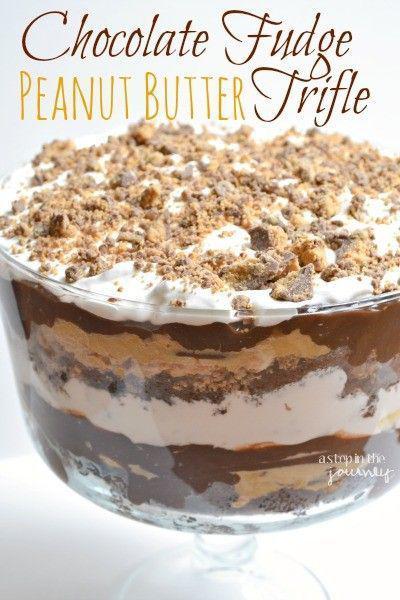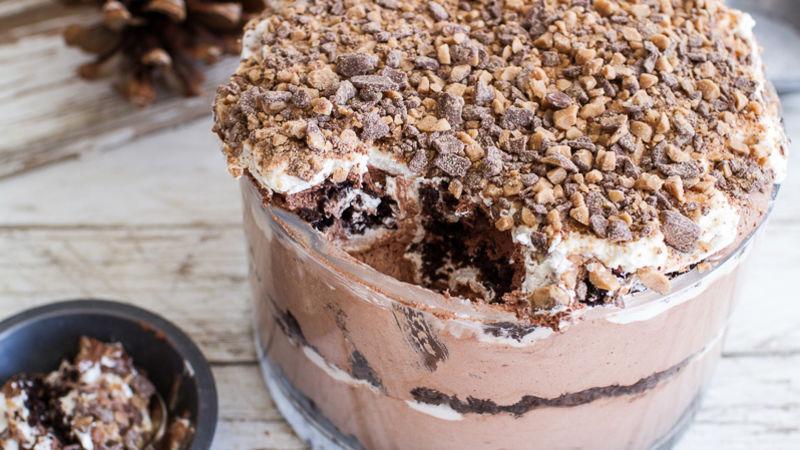The first image is the image on the left, the second image is the image on the right. Examine the images to the left and right. Is the description "Left image shows a dessert served in a footed glass with crumble-type garnish nearly covering the top." accurate? Answer yes or no. Yes. 